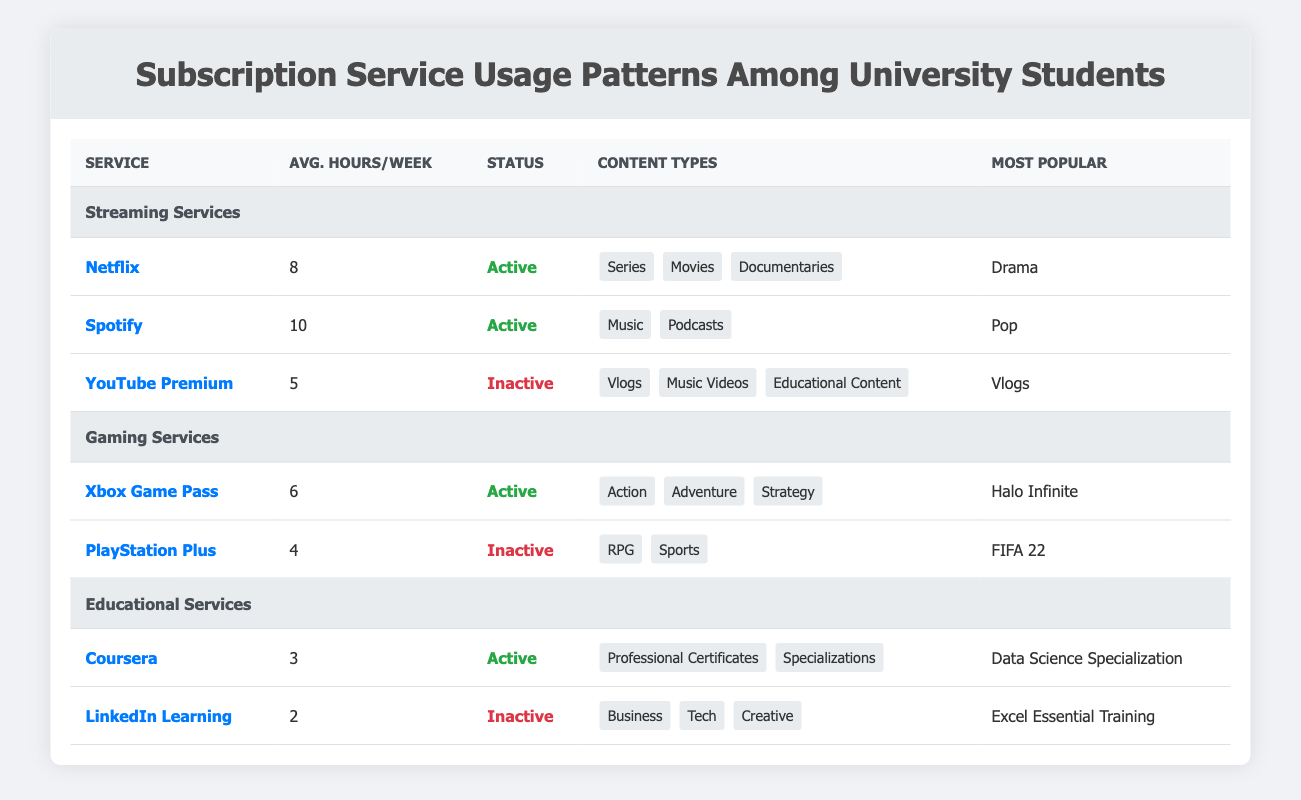What is the average hours per week spent on streaming services? To find the average, we gather the average hours for Netflix (8), Spotify (10), and YouTube Premium (5). Adding these values gives us a total of 23 hours (8 + 10 + 5 = 23). Dividing by the number of services (3) results in an average of 23/3, which equals approximately 7.67 hours.
Answer: 7.67 Is Spotify an active subscription service? The table shows that Spotify has a subscription status of "active." This indicates that users are currently subscribed to the service.
Answer: Yes Which gaming service has the most played game listed? The gaming services listed are Xbox Game Pass with "Halo Infinite" and PlayStation Plus with "FIFA 22." Since Xbox Game Pass is the only service with a game listed as the most played, it does not require comparison.
Answer: Xbox Game Pass What is the average hours per week spent on educational services? The average hours for Coursera is 3 hours and for LinkedIn Learning is 2 hours. Adding these together gives a total of 5 hours (3 + 2 = 5). Dividing this total by the number of services (2) results in an average of 5/2 = 2.5 hours.
Answer: 2.5 Is it true that more time is spent on Spotify than on Netflix? The average hours spent on Spotify is 10 hours per week, while on Netflix, it is 8 hours per week. Since 10 is greater than 8, the statement is indeed true.
Answer: Yes Which subscription service has inactive status and offers music-related content? YouTube Premium is listed as inactive and has content types including "music videos," which relates to music content. Thus, it meets the criteria of being inactive and offering music-related content.
Answer: YouTube Premium How many average hours per week are spent on gaming services combined? Xbox Game Pass averages 6 hours per week and PlayStation Plus averages 4 hours per week. Adding these gives 10 hours (6 + 4 = 10). This is the total combined average hours per week spent on both gaming services.
Answer: 10 What is the most completed course on Coursera according to the table? According to the table, the most completed course on Coursera is the "Data Science Specialization." This is explicitly stated under the details for Coursera's usage patterns.
Answer: Data Science Specialization Are any educational services currently inactive? The table records LinkedIn Learning as "inactive." Therefore, it confirms that there is indeed an educational service that is not currently active.
Answer: Yes 